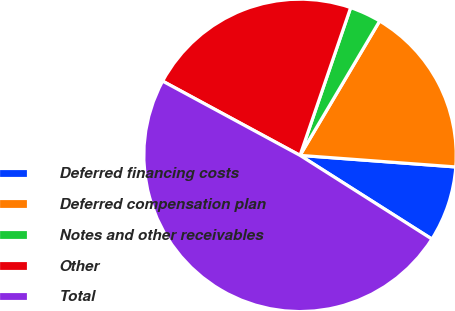Convert chart. <chart><loc_0><loc_0><loc_500><loc_500><pie_chart><fcel>Deferred financing costs<fcel>Deferred compensation plan<fcel>Notes and other receivables<fcel>Other<fcel>Total<nl><fcel>7.82%<fcel>17.67%<fcel>3.26%<fcel>22.37%<fcel>48.89%<nl></chart> 